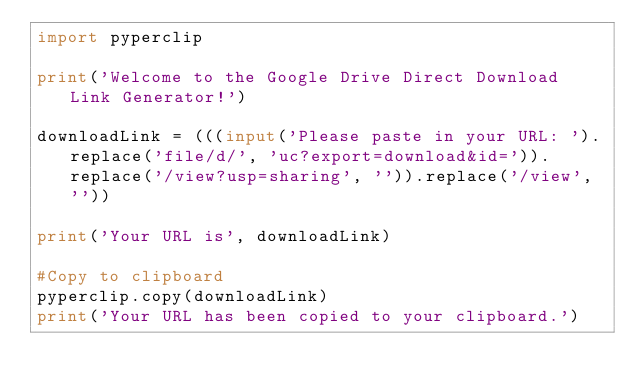Convert code to text. <code><loc_0><loc_0><loc_500><loc_500><_Python_>import pyperclip

print('Welcome to the Google Drive Direct Download Link Generator!')

downloadLink = (((input('Please paste in your URL: ').replace('file/d/', 'uc?export=download&id=')).replace('/view?usp=sharing', '')).replace('/view', ''))

print('Your URL is', downloadLink)

#Copy to clipboard
pyperclip.copy(downloadLink)
print('Your URL has been copied to your clipboard.')
</code> 